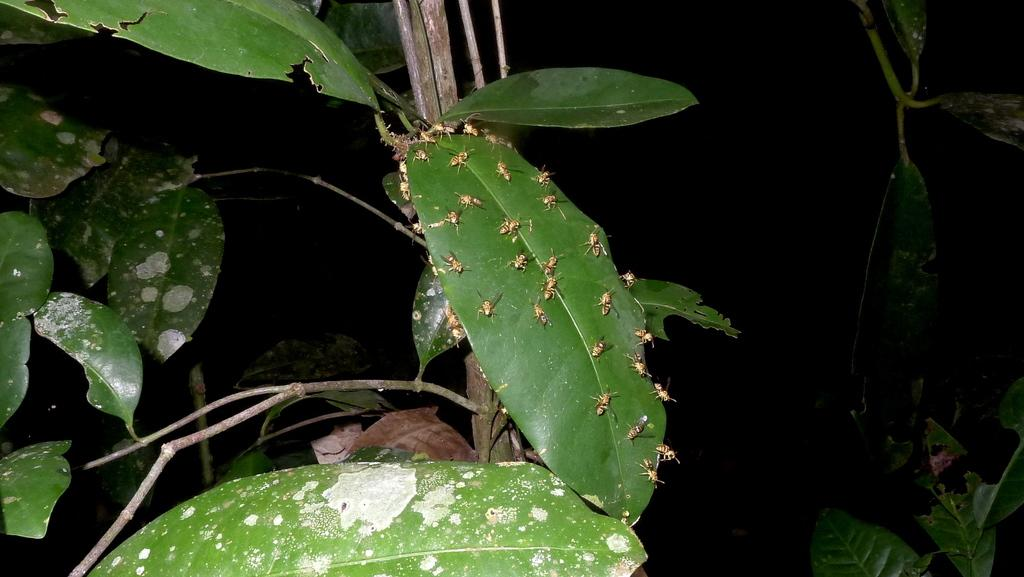What type of plant is visible in the image? There is a tree with leaves in the image. Are there any living organisms on the tree? Yes, insects are present on the leaves of the tree. What can be observed about the background of the image? The background of the image is dark. What is the name of the grandmother who lives near the tree in the image? There is no mention of a grandmother or any person in the image, so it is not possible to answer that question. 